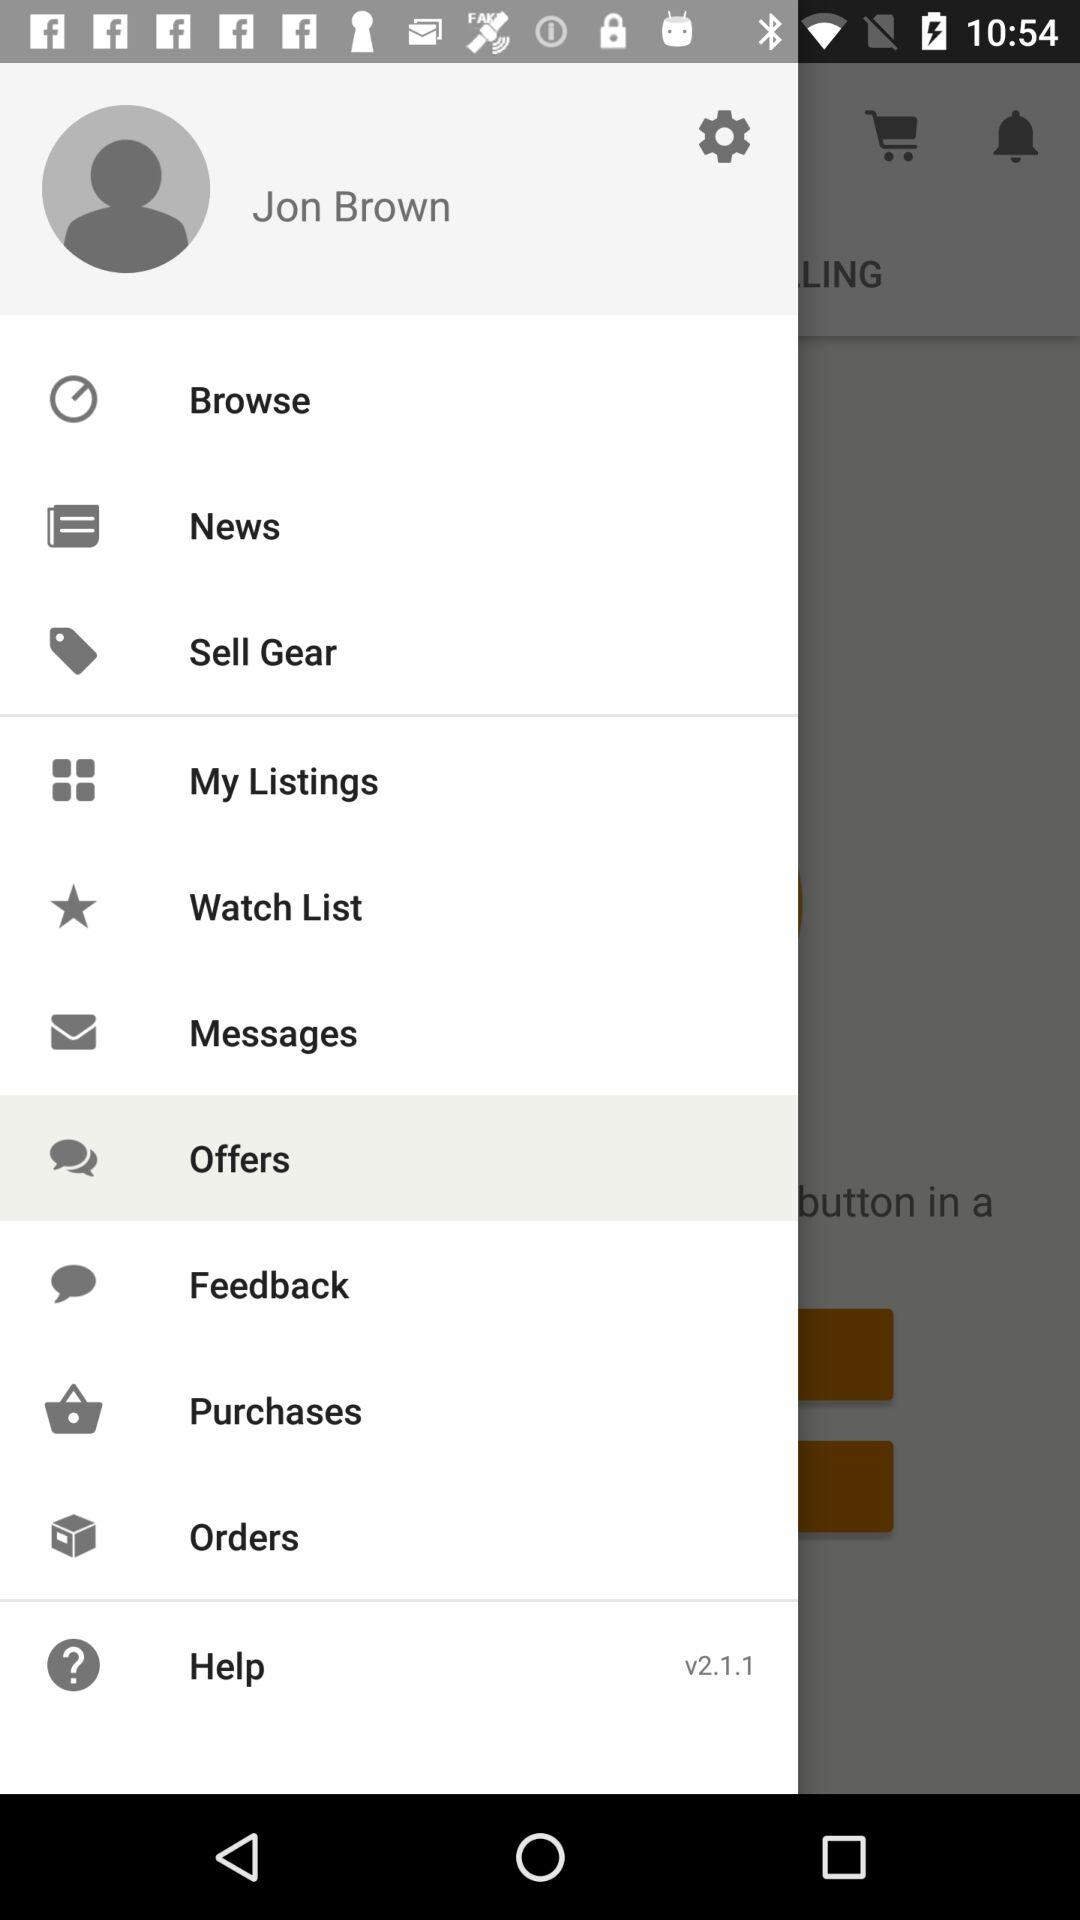What is the profile name? The profile name is Jon Brown. 